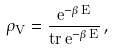<formula> <loc_0><loc_0><loc_500><loc_500>\rho _ { V } = \frac { e ^ { - \beta \, E } } { t r \, e ^ { - \beta \, E } } \, ,</formula> 